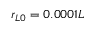<formula> <loc_0><loc_0><loc_500><loc_500>r _ { L 0 } = 0 . 0 0 0 1 L</formula> 